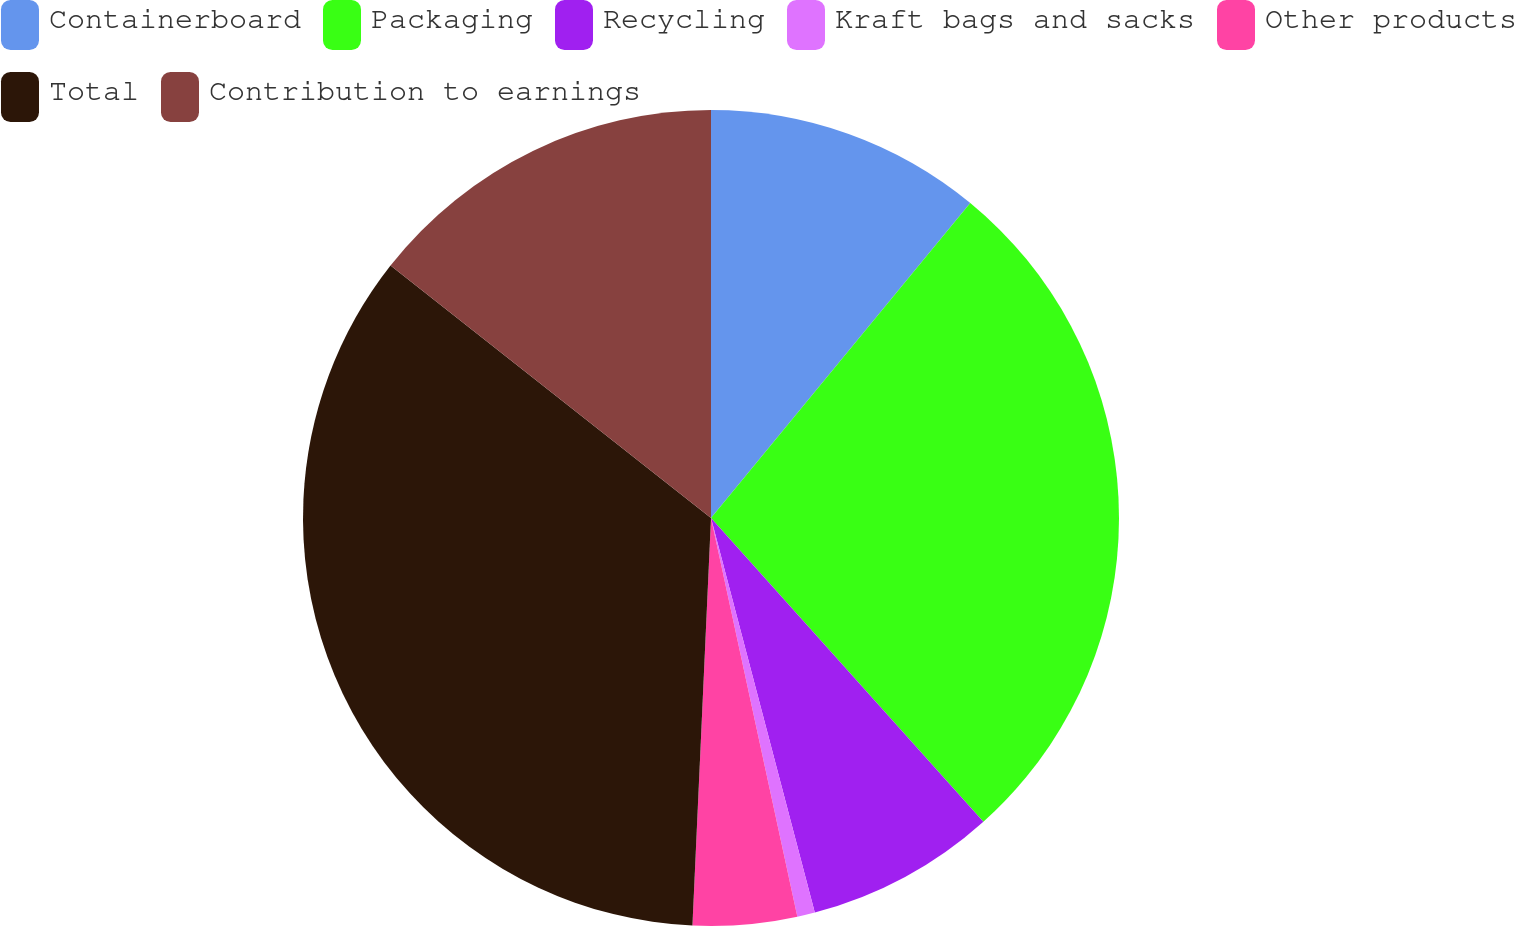Convert chart. <chart><loc_0><loc_0><loc_500><loc_500><pie_chart><fcel>Containerboard<fcel>Packaging<fcel>Recycling<fcel>Kraft bags and sacks<fcel>Other products<fcel>Total<fcel>Contribution to earnings<nl><fcel>10.96%<fcel>27.41%<fcel>7.54%<fcel>0.7%<fcel>4.12%<fcel>34.9%<fcel>14.38%<nl></chart> 